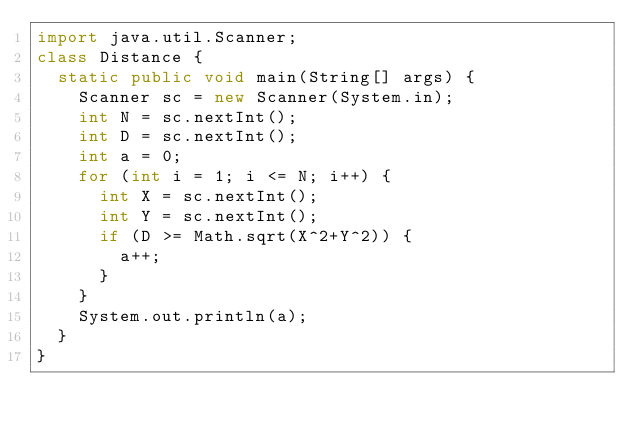<code> <loc_0><loc_0><loc_500><loc_500><_Java_>import java.util.Scanner;
class Distance {
  static public void main(String[] args) {
    Scanner sc = new Scanner(System.in);
    int N = sc.nextInt();
    int D = sc.nextInt();
    int a = 0;
    for (int i = 1; i <= N; i++) {
      int X = sc.nextInt();
      int Y = sc.nextInt();
      if (D >= Math.sqrt(X^2+Y^2)) {
        a++;
      }
    }
    System.out.println(a);
  }
}</code> 